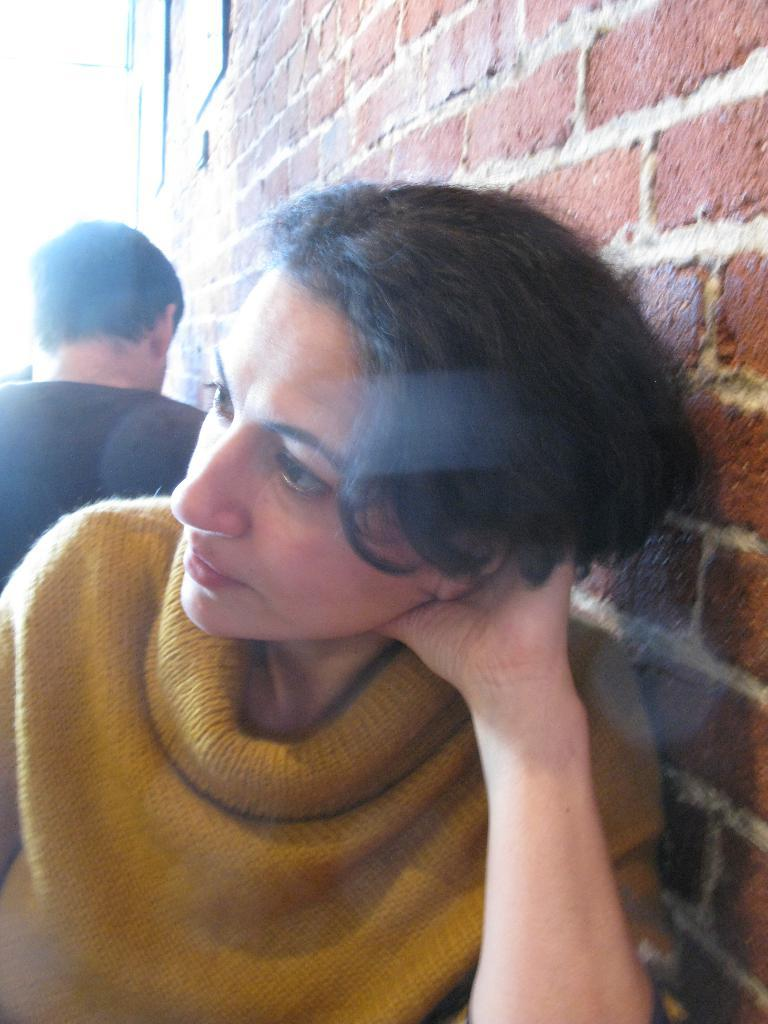Who is the main subject in the image? There is a lady in the image. What is the lady doing in the image? The lady is sitting. Can you describe the position of the man in relation to the lady? There is a man behind the lady. What can be seen in the background of the image? There is a wall in the background of the image. What type of goat can be seen walking in the image? There is no goat present in the image, and therefore no such activity can be observed. 